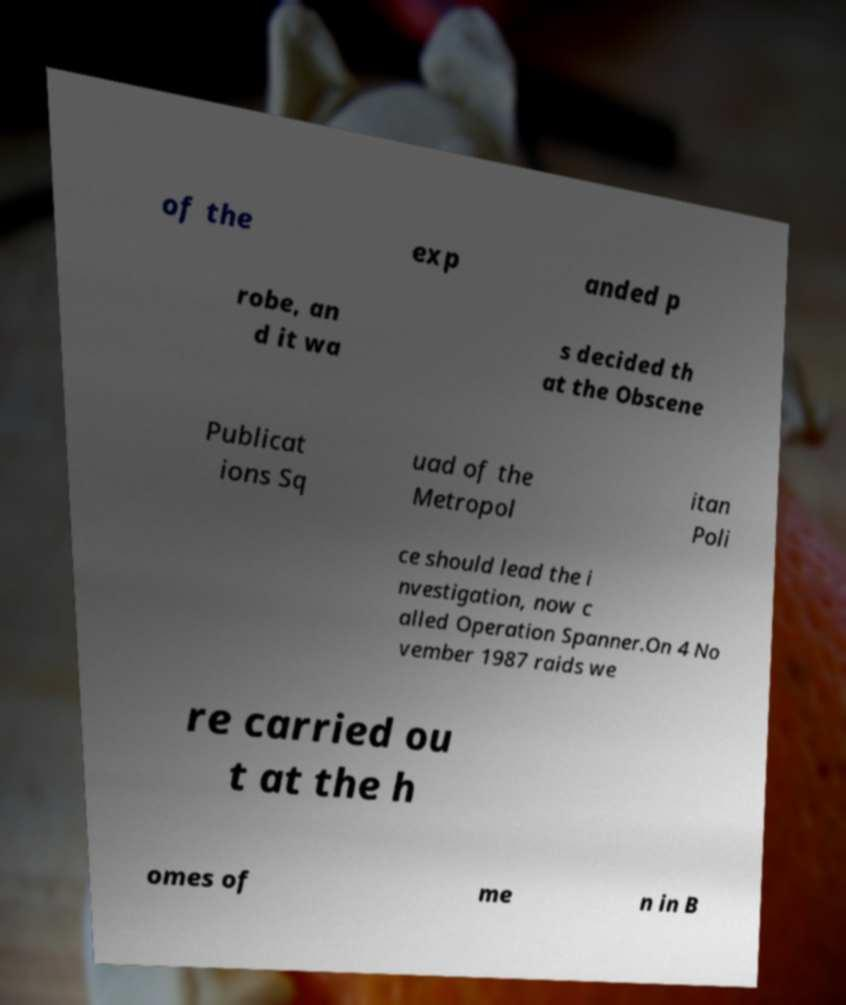I need the written content from this picture converted into text. Can you do that? of the exp anded p robe, an d it wa s decided th at the Obscene Publicat ions Sq uad of the Metropol itan Poli ce should lead the i nvestigation, now c alled Operation Spanner.On 4 No vember 1987 raids we re carried ou t at the h omes of me n in B 